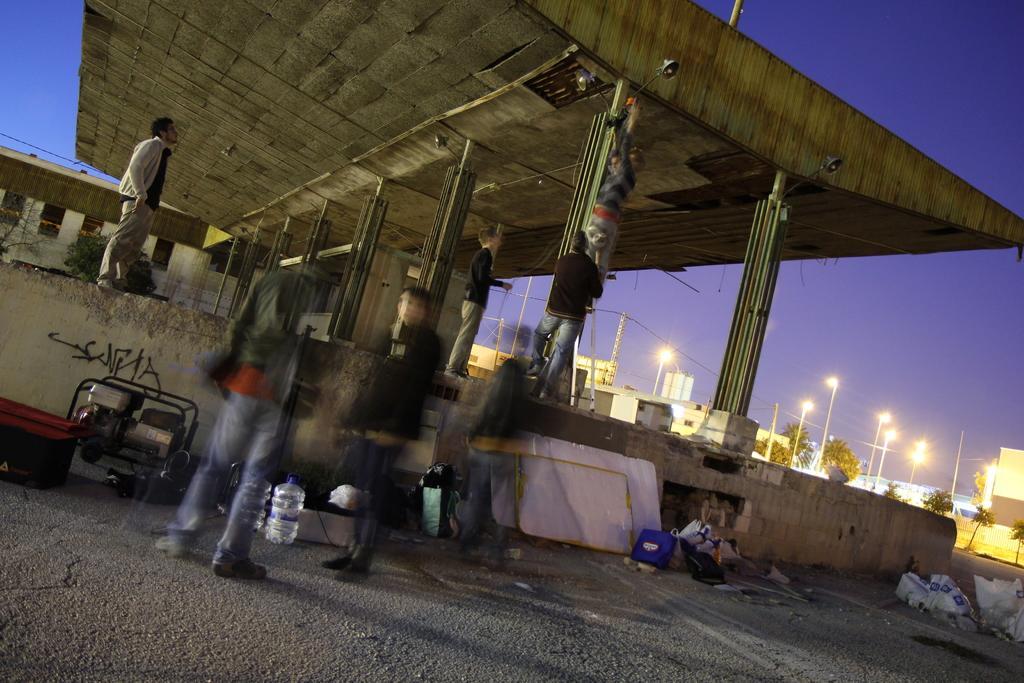Describe this image in one or two sentences. In this image, we can see a shelter. There are some persons standing and wearing clothes. There are some street poles on the right side of the image. There is a machine and tins on the left side of the image. In the background of the image, there is a sky. 